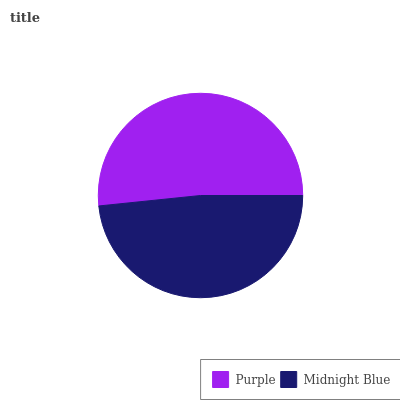Is Midnight Blue the minimum?
Answer yes or no. Yes. Is Purple the maximum?
Answer yes or no. Yes. Is Midnight Blue the maximum?
Answer yes or no. No. Is Purple greater than Midnight Blue?
Answer yes or no. Yes. Is Midnight Blue less than Purple?
Answer yes or no. Yes. Is Midnight Blue greater than Purple?
Answer yes or no. No. Is Purple less than Midnight Blue?
Answer yes or no. No. Is Purple the high median?
Answer yes or no. Yes. Is Midnight Blue the low median?
Answer yes or no. Yes. Is Midnight Blue the high median?
Answer yes or no. No. Is Purple the low median?
Answer yes or no. No. 